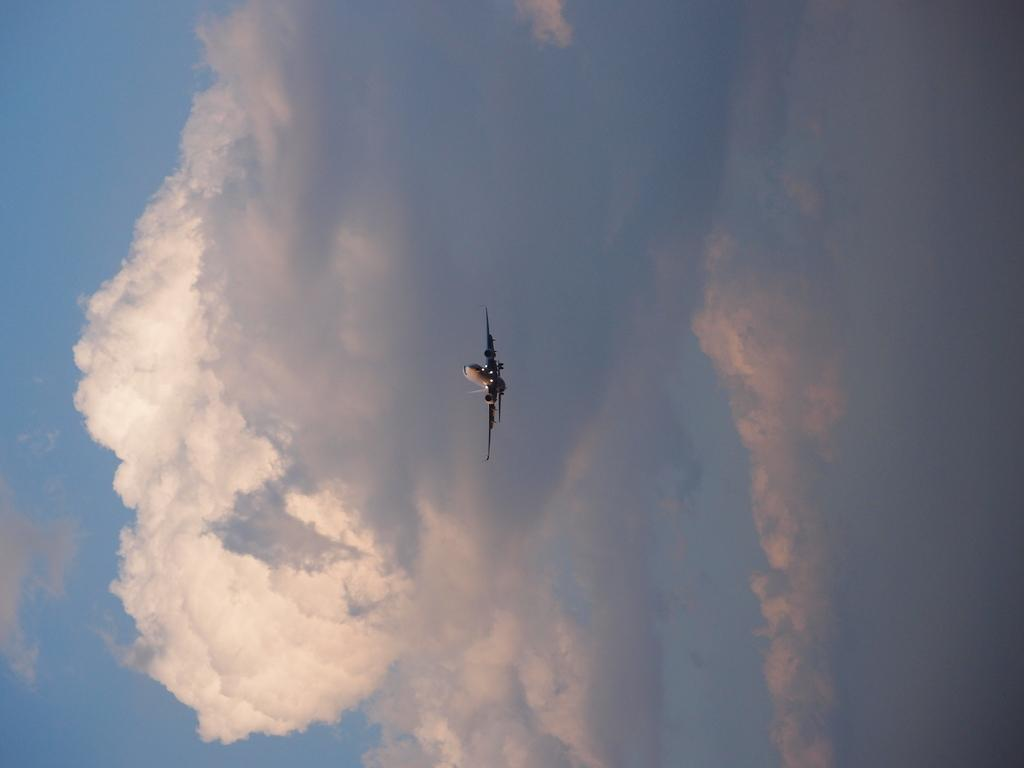What is the main subject of the image? The main subject of the image is an airplane. What is the airplane doing in the image? The airplane is flying in the air. What can be seen in the background of the image? The sky is visible in the background of the image. What else is present in the sky? Clouds are present in the sky. What type of yarn is being used to create the reaction of the airplane in the image? There is no yarn or reaction present in the image; it simply shows an airplane flying in the sky. 